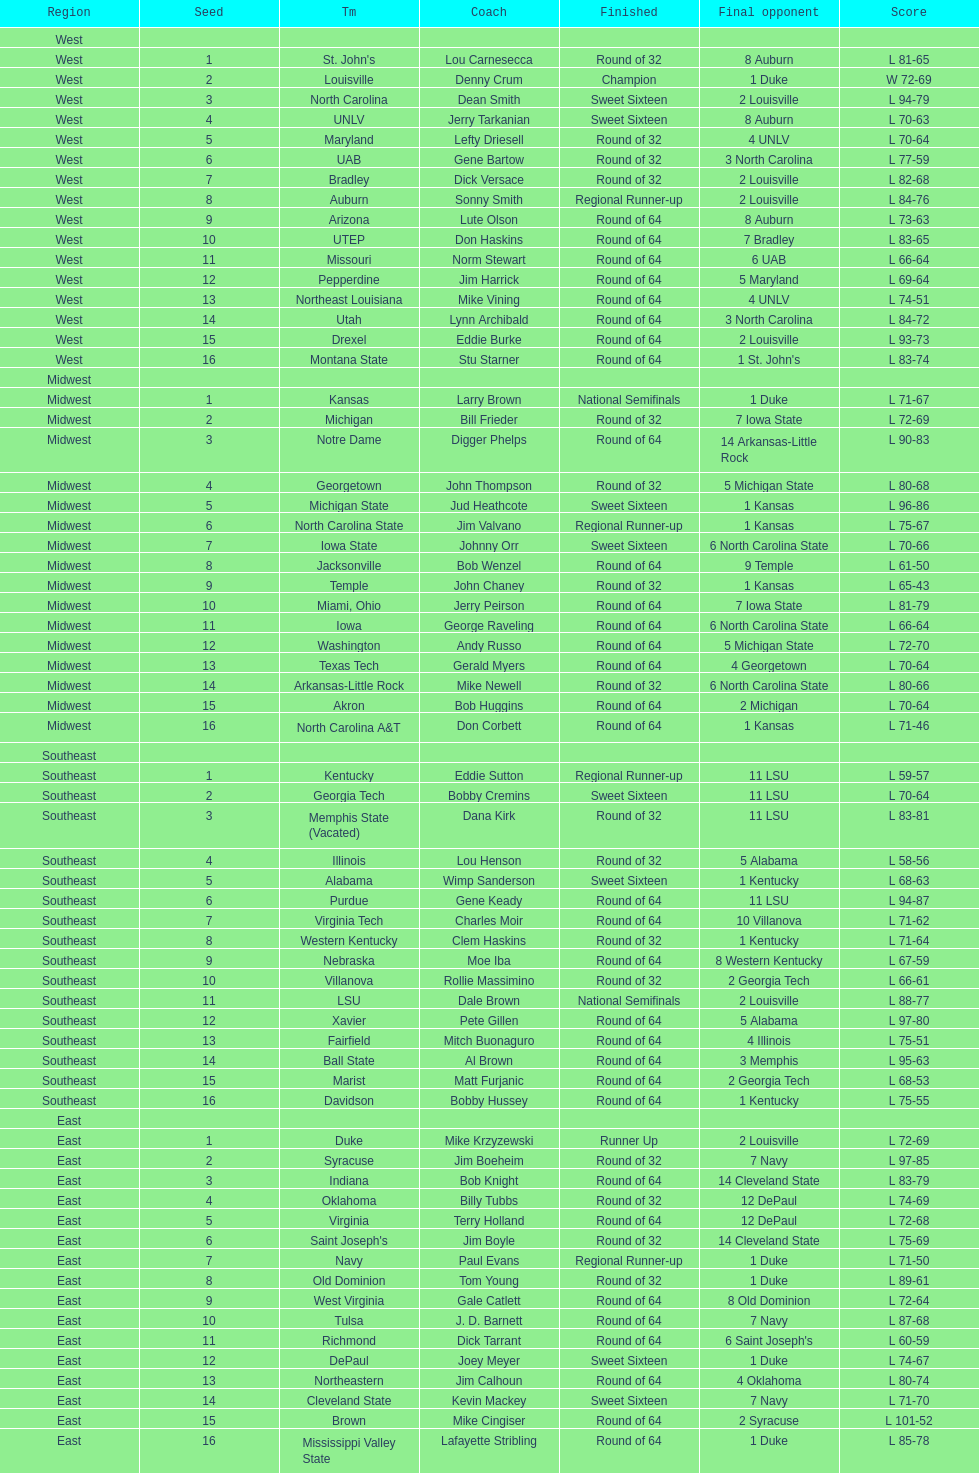How many 1 seeds are there? 4. Parse the full table. {'header': ['Region', 'Seed', 'Tm', 'Coach', 'Finished', 'Final opponent', 'Score'], 'rows': [['West', '', '', '', '', '', ''], ['West', '1', "St. John's", 'Lou Carnesecca', 'Round of 32', '8 Auburn', 'L 81-65'], ['West', '2', 'Louisville', 'Denny Crum', 'Champion', '1 Duke', 'W 72-69'], ['West', '3', 'North Carolina', 'Dean Smith', 'Sweet Sixteen', '2 Louisville', 'L 94-79'], ['West', '4', 'UNLV', 'Jerry Tarkanian', 'Sweet Sixteen', '8 Auburn', 'L 70-63'], ['West', '5', 'Maryland', 'Lefty Driesell', 'Round of 32', '4 UNLV', 'L 70-64'], ['West', '6', 'UAB', 'Gene Bartow', 'Round of 32', '3 North Carolina', 'L 77-59'], ['West', '7', 'Bradley', 'Dick Versace', 'Round of 32', '2 Louisville', 'L 82-68'], ['West', '8', 'Auburn', 'Sonny Smith', 'Regional Runner-up', '2 Louisville', 'L 84-76'], ['West', '9', 'Arizona', 'Lute Olson', 'Round of 64', '8 Auburn', 'L 73-63'], ['West', '10', 'UTEP', 'Don Haskins', 'Round of 64', '7 Bradley', 'L 83-65'], ['West', '11', 'Missouri', 'Norm Stewart', 'Round of 64', '6 UAB', 'L 66-64'], ['West', '12', 'Pepperdine', 'Jim Harrick', 'Round of 64', '5 Maryland', 'L 69-64'], ['West', '13', 'Northeast Louisiana', 'Mike Vining', 'Round of 64', '4 UNLV', 'L 74-51'], ['West', '14', 'Utah', 'Lynn Archibald', 'Round of 64', '3 North Carolina', 'L 84-72'], ['West', '15', 'Drexel', 'Eddie Burke', 'Round of 64', '2 Louisville', 'L 93-73'], ['West', '16', 'Montana State', 'Stu Starner', 'Round of 64', "1 St. John's", 'L 83-74'], ['Midwest', '', '', '', '', '', ''], ['Midwest', '1', 'Kansas', 'Larry Brown', 'National Semifinals', '1 Duke', 'L 71-67'], ['Midwest', '2', 'Michigan', 'Bill Frieder', 'Round of 32', '7 Iowa State', 'L 72-69'], ['Midwest', '3', 'Notre Dame', 'Digger Phelps', 'Round of 64', '14 Arkansas-Little Rock', 'L 90-83'], ['Midwest', '4', 'Georgetown', 'John Thompson', 'Round of 32', '5 Michigan State', 'L 80-68'], ['Midwest', '5', 'Michigan State', 'Jud Heathcote', 'Sweet Sixteen', '1 Kansas', 'L 96-86'], ['Midwest', '6', 'North Carolina State', 'Jim Valvano', 'Regional Runner-up', '1 Kansas', 'L 75-67'], ['Midwest', '7', 'Iowa State', 'Johnny Orr', 'Sweet Sixteen', '6 North Carolina State', 'L 70-66'], ['Midwest', '8', 'Jacksonville', 'Bob Wenzel', 'Round of 64', '9 Temple', 'L 61-50'], ['Midwest', '9', 'Temple', 'John Chaney', 'Round of 32', '1 Kansas', 'L 65-43'], ['Midwest', '10', 'Miami, Ohio', 'Jerry Peirson', 'Round of 64', '7 Iowa State', 'L 81-79'], ['Midwest', '11', 'Iowa', 'George Raveling', 'Round of 64', '6 North Carolina State', 'L 66-64'], ['Midwest', '12', 'Washington', 'Andy Russo', 'Round of 64', '5 Michigan State', 'L 72-70'], ['Midwest', '13', 'Texas Tech', 'Gerald Myers', 'Round of 64', '4 Georgetown', 'L 70-64'], ['Midwest', '14', 'Arkansas-Little Rock', 'Mike Newell', 'Round of 32', '6 North Carolina State', 'L 80-66'], ['Midwest', '15', 'Akron', 'Bob Huggins', 'Round of 64', '2 Michigan', 'L 70-64'], ['Midwest', '16', 'North Carolina A&T', 'Don Corbett', 'Round of 64', '1 Kansas', 'L 71-46'], ['Southeast', '', '', '', '', '', ''], ['Southeast', '1', 'Kentucky', 'Eddie Sutton', 'Regional Runner-up', '11 LSU', 'L 59-57'], ['Southeast', '2', 'Georgia Tech', 'Bobby Cremins', 'Sweet Sixteen', '11 LSU', 'L 70-64'], ['Southeast', '3', 'Memphis State (Vacated)', 'Dana Kirk', 'Round of 32', '11 LSU', 'L 83-81'], ['Southeast', '4', 'Illinois', 'Lou Henson', 'Round of 32', '5 Alabama', 'L 58-56'], ['Southeast', '5', 'Alabama', 'Wimp Sanderson', 'Sweet Sixteen', '1 Kentucky', 'L 68-63'], ['Southeast', '6', 'Purdue', 'Gene Keady', 'Round of 64', '11 LSU', 'L 94-87'], ['Southeast', '7', 'Virginia Tech', 'Charles Moir', 'Round of 64', '10 Villanova', 'L 71-62'], ['Southeast', '8', 'Western Kentucky', 'Clem Haskins', 'Round of 32', '1 Kentucky', 'L 71-64'], ['Southeast', '9', 'Nebraska', 'Moe Iba', 'Round of 64', '8 Western Kentucky', 'L 67-59'], ['Southeast', '10', 'Villanova', 'Rollie Massimino', 'Round of 32', '2 Georgia Tech', 'L 66-61'], ['Southeast', '11', 'LSU', 'Dale Brown', 'National Semifinals', '2 Louisville', 'L 88-77'], ['Southeast', '12', 'Xavier', 'Pete Gillen', 'Round of 64', '5 Alabama', 'L 97-80'], ['Southeast', '13', 'Fairfield', 'Mitch Buonaguro', 'Round of 64', '4 Illinois', 'L 75-51'], ['Southeast', '14', 'Ball State', 'Al Brown', 'Round of 64', '3 Memphis', 'L 95-63'], ['Southeast', '15', 'Marist', 'Matt Furjanic', 'Round of 64', '2 Georgia Tech', 'L 68-53'], ['Southeast', '16', 'Davidson', 'Bobby Hussey', 'Round of 64', '1 Kentucky', 'L 75-55'], ['East', '', '', '', '', '', ''], ['East', '1', 'Duke', 'Mike Krzyzewski', 'Runner Up', '2 Louisville', 'L 72-69'], ['East', '2', 'Syracuse', 'Jim Boeheim', 'Round of 32', '7 Navy', 'L 97-85'], ['East', '3', 'Indiana', 'Bob Knight', 'Round of 64', '14 Cleveland State', 'L 83-79'], ['East', '4', 'Oklahoma', 'Billy Tubbs', 'Round of 32', '12 DePaul', 'L 74-69'], ['East', '5', 'Virginia', 'Terry Holland', 'Round of 64', '12 DePaul', 'L 72-68'], ['East', '6', "Saint Joseph's", 'Jim Boyle', 'Round of 32', '14 Cleveland State', 'L 75-69'], ['East', '7', 'Navy', 'Paul Evans', 'Regional Runner-up', '1 Duke', 'L 71-50'], ['East', '8', 'Old Dominion', 'Tom Young', 'Round of 32', '1 Duke', 'L 89-61'], ['East', '9', 'West Virginia', 'Gale Catlett', 'Round of 64', '8 Old Dominion', 'L 72-64'], ['East', '10', 'Tulsa', 'J. D. Barnett', 'Round of 64', '7 Navy', 'L 87-68'], ['East', '11', 'Richmond', 'Dick Tarrant', 'Round of 64', "6 Saint Joseph's", 'L 60-59'], ['East', '12', 'DePaul', 'Joey Meyer', 'Sweet Sixteen', '1 Duke', 'L 74-67'], ['East', '13', 'Northeastern', 'Jim Calhoun', 'Round of 64', '4 Oklahoma', 'L 80-74'], ['East', '14', 'Cleveland State', 'Kevin Mackey', 'Sweet Sixteen', '7 Navy', 'L 71-70'], ['East', '15', 'Brown', 'Mike Cingiser', 'Round of 64', '2 Syracuse', 'L 101-52'], ['East', '16', 'Mississippi Valley State', 'Lafayette Stribling', 'Round of 64', '1 Duke', 'L 85-78']]} 